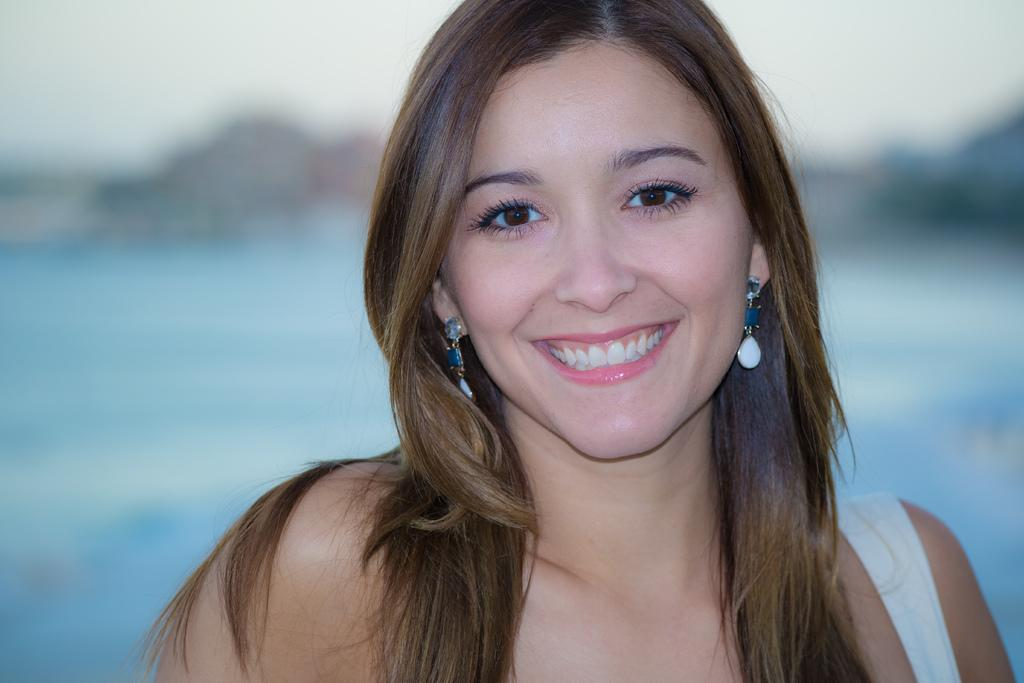Who is present in the image? There is a woman in the image. What is the appearance of the woman's hair? The woman has loose hair. What is the woman's facial expression? The woman is smiling. What can be seen in the background of the image? There is a water surface visible in the background of the image, although it is not clearly visible. How many friends does the woman have with her in the image? The image only shows the woman, so it is not possible to determine how many friends she has with her. What type of fowl can be seen in the image? There is no fowl present in the image. 